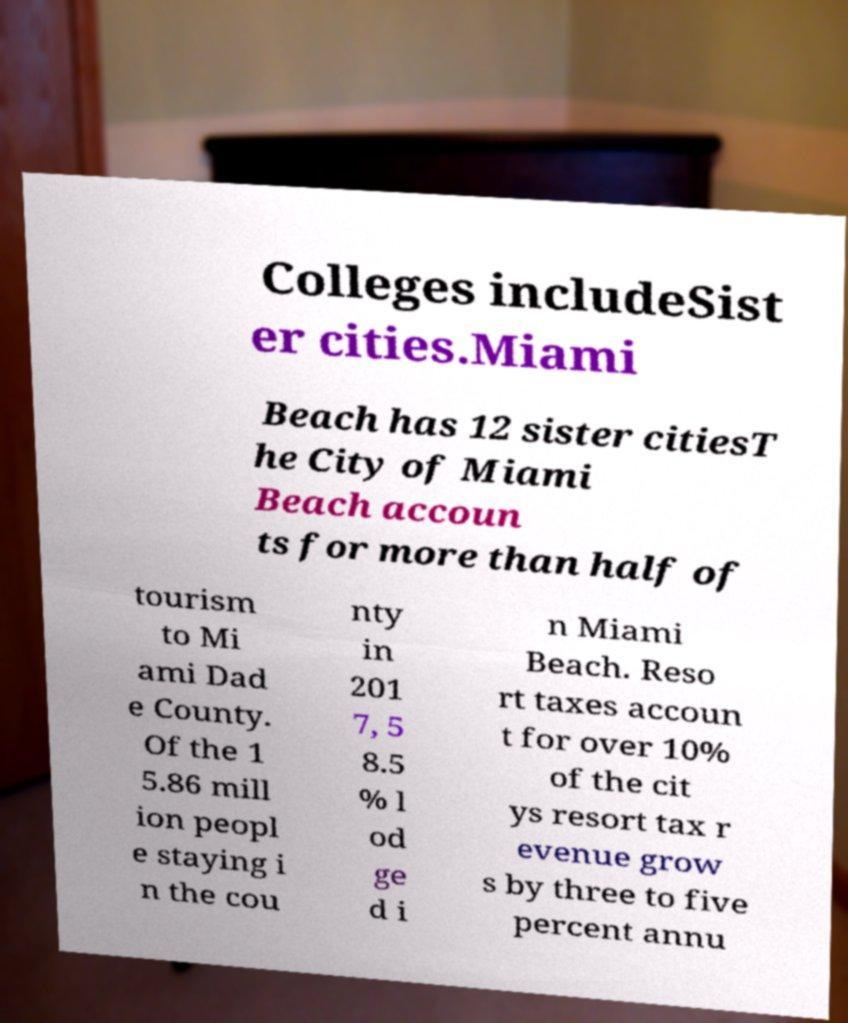I need the written content from this picture converted into text. Can you do that? Colleges includeSist er cities.Miami Beach has 12 sister citiesT he City of Miami Beach accoun ts for more than half of tourism to Mi ami Dad e County. Of the 1 5.86 mill ion peopl e staying i n the cou nty in 201 7, 5 8.5 % l od ge d i n Miami Beach. Reso rt taxes accoun t for over 10% of the cit ys resort tax r evenue grow s by three to five percent annu 